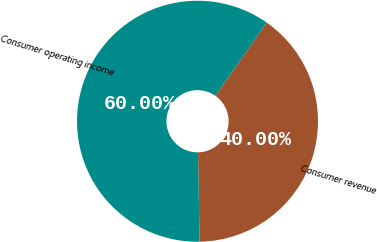Convert chart to OTSL. <chart><loc_0><loc_0><loc_500><loc_500><pie_chart><fcel>Consumer revenue<fcel>Consumer operating income<nl><fcel>40.0%<fcel>60.0%<nl></chart> 